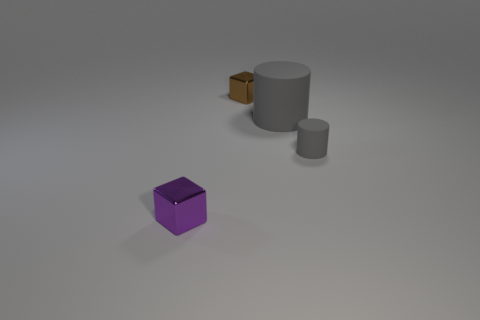There is a metal thing behind the tiny gray matte thing; what shape is it?
Make the answer very short. Cube. Does the large thing have the same shape as the small brown object?
Ensure brevity in your answer.  No. Is the number of objects in front of the tiny gray matte cylinder the same as the number of tiny purple metallic things?
Make the answer very short. Yes. The tiny gray object has what shape?
Provide a short and direct response. Cylinder. Are there any other things that have the same color as the small matte object?
Keep it short and to the point. Yes. Does the cube that is in front of the small cylinder have the same size as the object right of the big object?
Your answer should be compact. Yes. There is a metal thing that is in front of the gray rubber cylinder that is on the right side of the big gray cylinder; what is its shape?
Give a very brief answer. Cube. There is a purple cube; is its size the same as the metal object that is right of the purple thing?
Give a very brief answer. Yes. How big is the rubber cylinder left of the tiny gray matte cylinder behind the shiny cube in front of the tiny gray object?
Make the answer very short. Large. What number of objects are shiny cubes that are to the left of the tiny brown metal block or blocks?
Ensure brevity in your answer.  2. 